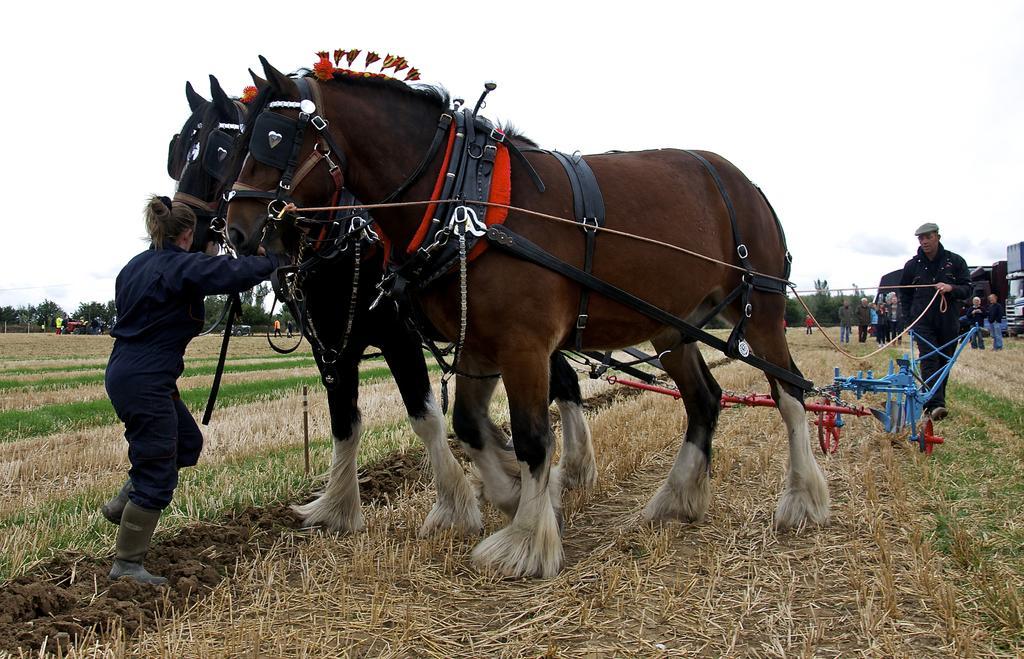Can you describe this image briefly? In this image I can see two horses standing on the grass. These horses are in brown color. I can see one person is holding the rope of the horse and there is a person in-front of the horse. To the side I can see few more people standing and wearing the different color dresses. In the background there are many trees and the white sky. 